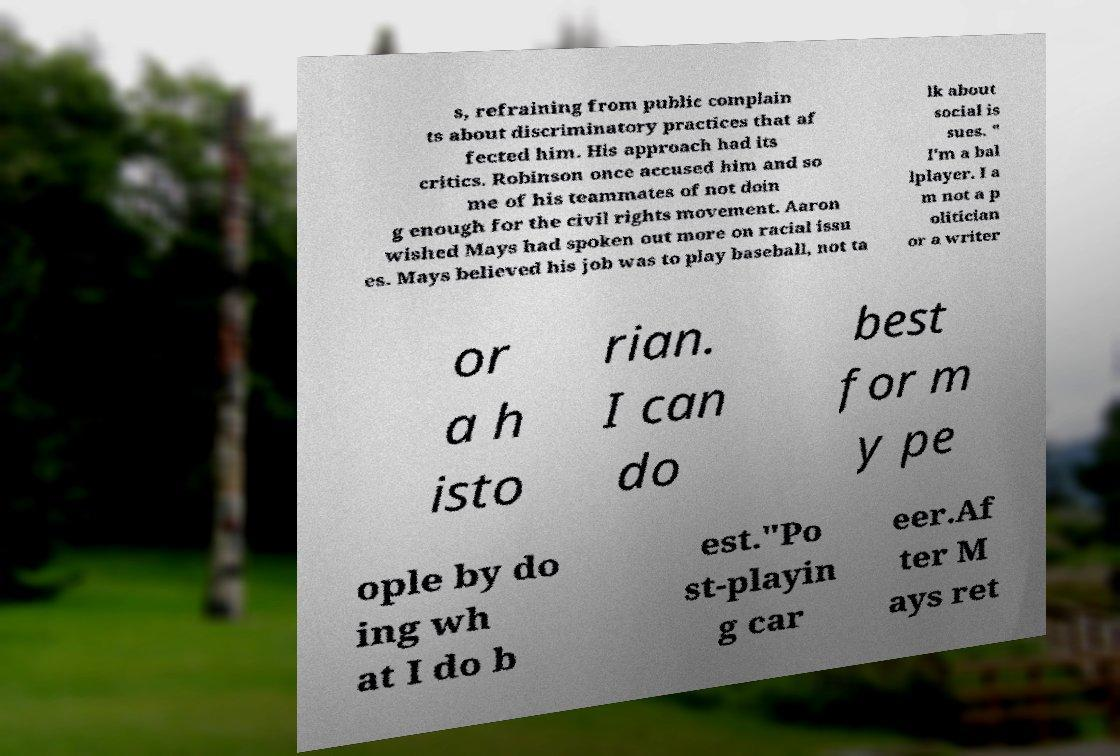Please read and relay the text visible in this image. What does it say? s, refraining from public complain ts about discriminatory practices that af fected him. His approach had its critics. Robinson once accused him and so me of his teammates of not doin g enough for the civil rights movement. Aaron wished Mays had spoken out more on racial issu es. Mays believed his job was to play baseball, not ta lk about social is sues. " I'm a bal lplayer. I a m not a p olitician or a writer or a h isto rian. I can do best for m y pe ople by do ing wh at I do b est."Po st-playin g car eer.Af ter M ays ret 